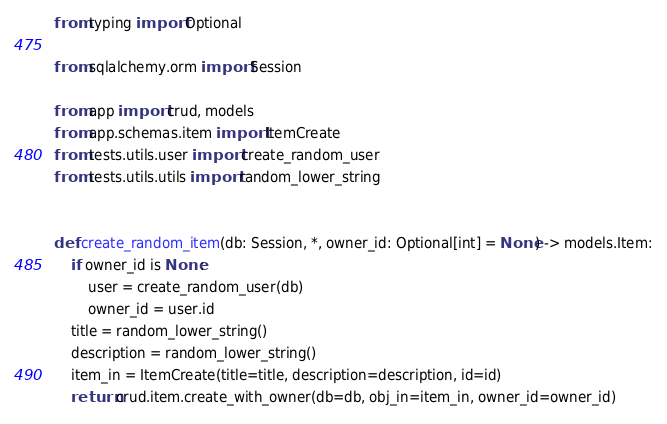<code> <loc_0><loc_0><loc_500><loc_500><_Python_>from typing import Optional

from sqlalchemy.orm import Session

from app import crud, models
from app.schemas.item import ItemCreate
from tests.utils.user import create_random_user
from tests.utils.utils import random_lower_string


def create_random_item(db: Session, *, owner_id: Optional[int] = None) -> models.Item:
    if owner_id is None:
        user = create_random_user(db)
        owner_id = user.id
    title = random_lower_string()
    description = random_lower_string()
    item_in = ItemCreate(title=title, description=description, id=id)
    return crud.item.create_with_owner(db=db, obj_in=item_in, owner_id=owner_id)
</code> 